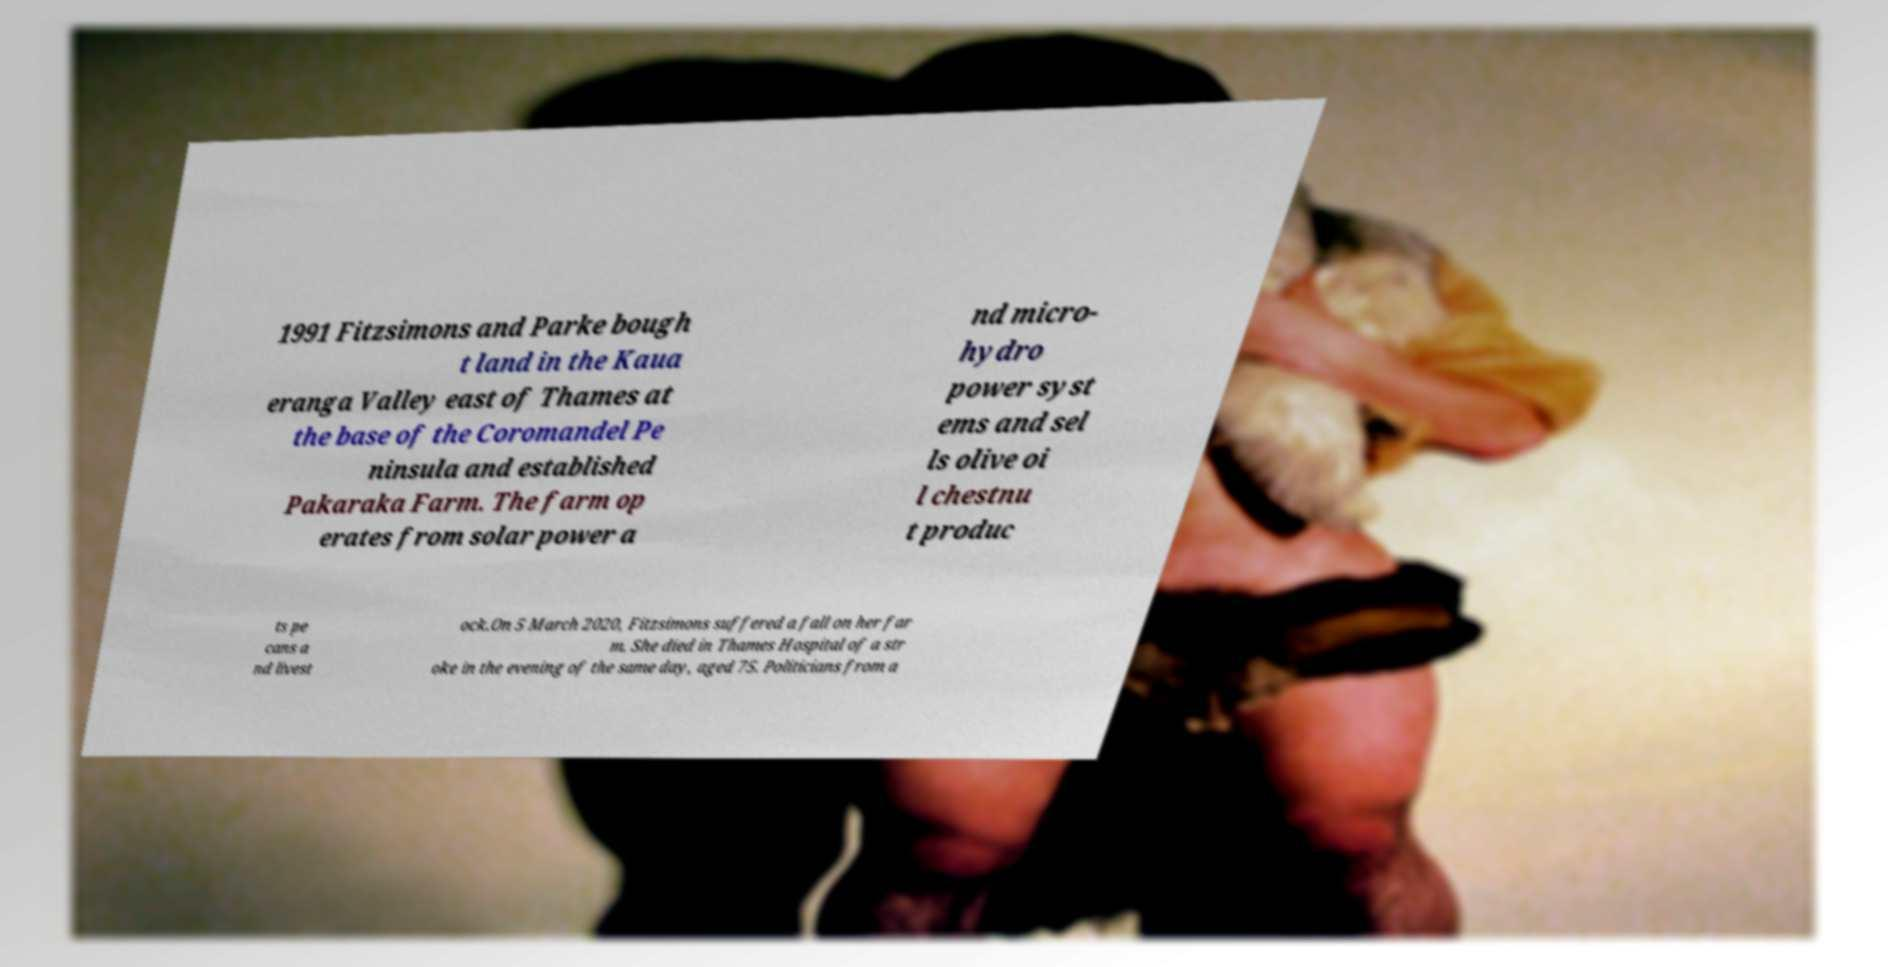I need the written content from this picture converted into text. Can you do that? 1991 Fitzsimons and Parke bough t land in the Kaua eranga Valley east of Thames at the base of the Coromandel Pe ninsula and established Pakaraka Farm. The farm op erates from solar power a nd micro- hydro power syst ems and sel ls olive oi l chestnu t produc ts pe cans a nd livest ock.On 5 March 2020, Fitzsimons suffered a fall on her far m. She died in Thames Hospital of a str oke in the evening of the same day, aged 75. Politicians from a 